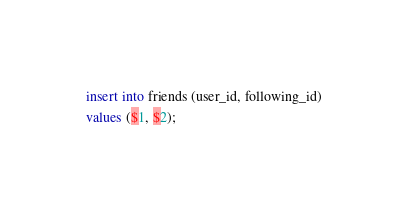<code> <loc_0><loc_0><loc_500><loc_500><_SQL_>insert into friends (user_id, following_id)
values ($1, $2);</code> 